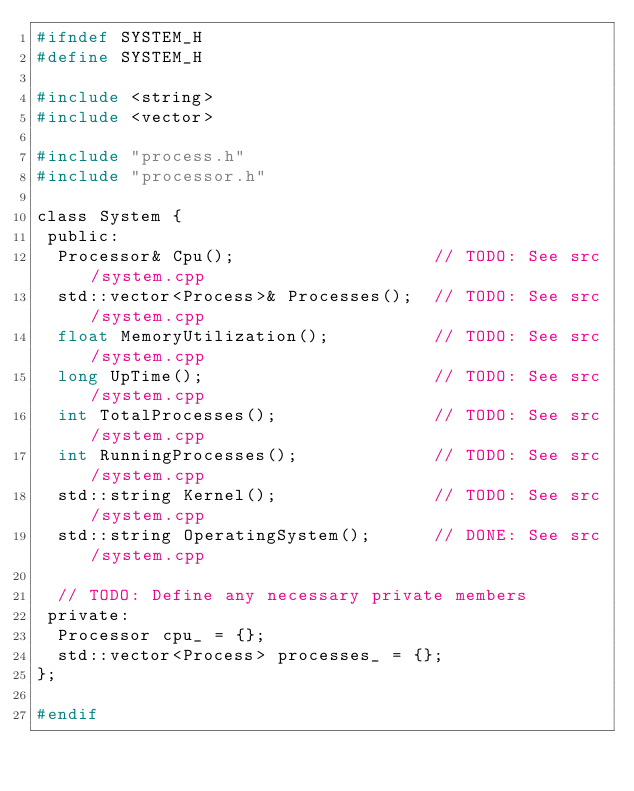<code> <loc_0><loc_0><loc_500><loc_500><_C_>#ifndef SYSTEM_H
#define SYSTEM_H

#include <string>
#include <vector>

#include "process.h"
#include "processor.h"

class System {
 public:
  Processor& Cpu();                   // TODO: See src/system.cpp
  std::vector<Process>& Processes();  // TODO: See src/system.cpp
  float MemoryUtilization();          // TODO: See src/system.cpp
  long UpTime();                      // TODO: See src/system.cpp
  int TotalProcesses();               // TODO: See src/system.cpp
  int RunningProcesses();             // TODO: See src/system.cpp
  std::string Kernel();               // TODO: See src/system.cpp
  std::string OperatingSystem();      // DONE: See src/system.cpp

  // TODO: Define any necessary private members
 private:
  Processor cpu_ = {};
  std::vector<Process> processes_ = {};
};

#endif</code> 